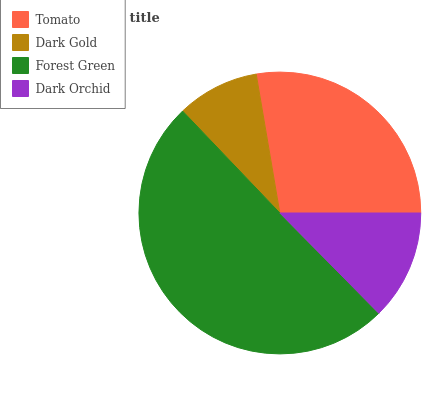Is Dark Gold the minimum?
Answer yes or no. Yes. Is Forest Green the maximum?
Answer yes or no. Yes. Is Forest Green the minimum?
Answer yes or no. No. Is Dark Gold the maximum?
Answer yes or no. No. Is Forest Green greater than Dark Gold?
Answer yes or no. Yes. Is Dark Gold less than Forest Green?
Answer yes or no. Yes. Is Dark Gold greater than Forest Green?
Answer yes or no. No. Is Forest Green less than Dark Gold?
Answer yes or no. No. Is Tomato the high median?
Answer yes or no. Yes. Is Dark Orchid the low median?
Answer yes or no. Yes. Is Forest Green the high median?
Answer yes or no. No. Is Forest Green the low median?
Answer yes or no. No. 